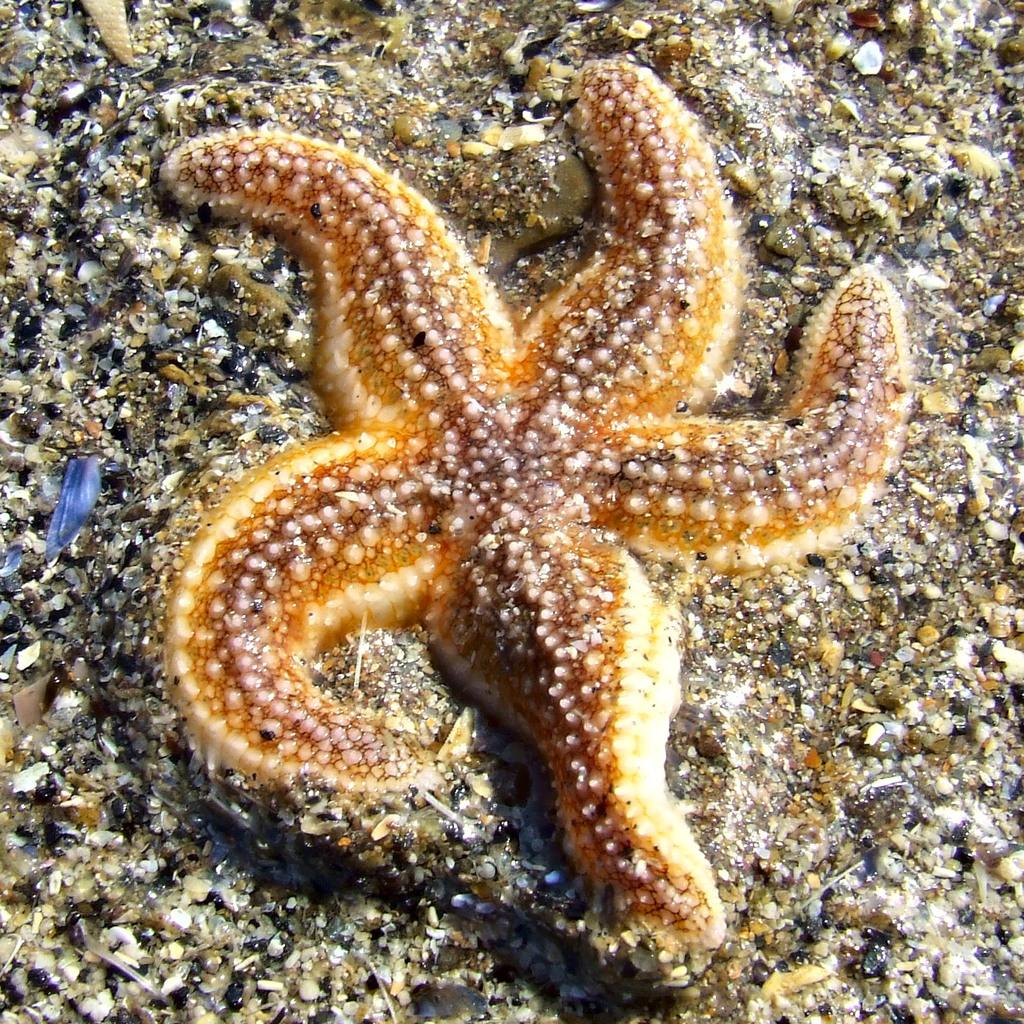What type of sea creature is in the image? There is a starfish in the image. Where is the starfish located? The starfish is on the ground. What else can be seen on the ground in the image? There are small stones on the ground in the image. What riddle does the starfish pose to the small stones in the image? There is no riddle present in the image; it simply shows a starfish and small stones on the ground. 